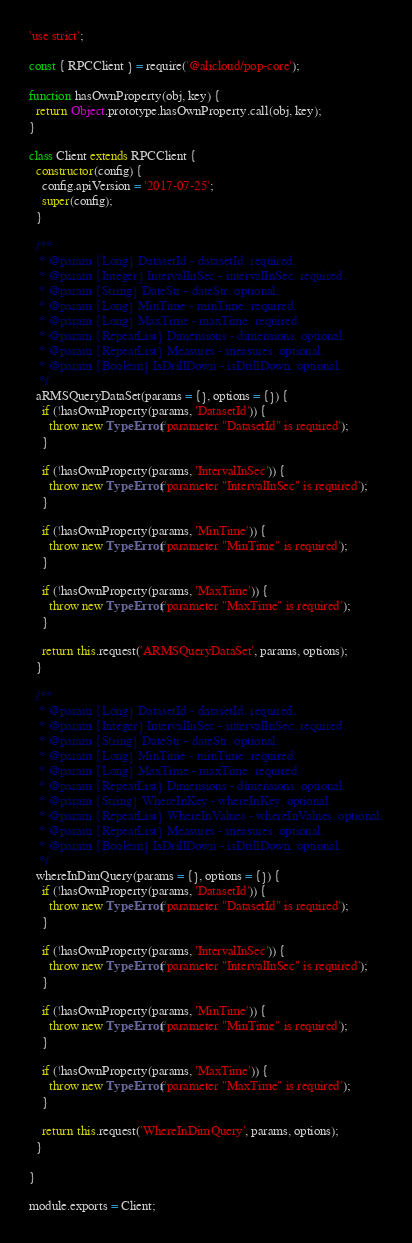<code> <loc_0><loc_0><loc_500><loc_500><_JavaScript_>
'use strict';

const { RPCClient } = require('@alicloud/pop-core');

function hasOwnProperty(obj, key) {
  return Object.prototype.hasOwnProperty.call(obj, key);
}

class Client extends RPCClient {
  constructor(config) {
    config.apiVersion = '2017-07-25';
    super(config);
  }

  /**
   * @param {Long} DatasetId - datasetId. required.
   * @param {Integer} IntervalInSec - intervalInSec. required.
   * @param {String} DateStr - dateStr. optional.
   * @param {Long} MinTime - minTime. required.
   * @param {Long} MaxTime - maxTime. required.
   * @param {RepeatList} Dimensions - dimensions. optional.
   * @param {RepeatList} Measures - measures. optional.
   * @param {Boolean} IsDrillDown - isDrillDown. optional.
   */
  aRMSQueryDataSet(params = {}, options = {}) {
    if (!hasOwnProperty(params, 'DatasetId')) {
      throw new TypeError('parameter "DatasetId" is required');
    }

    if (!hasOwnProperty(params, 'IntervalInSec')) {
      throw new TypeError('parameter "IntervalInSec" is required');
    }

    if (!hasOwnProperty(params, 'MinTime')) {
      throw new TypeError('parameter "MinTime" is required');
    }

    if (!hasOwnProperty(params, 'MaxTime')) {
      throw new TypeError('parameter "MaxTime" is required');
    }

    return this.request('ARMSQueryDataSet', params, options);
  }

  /**
   * @param {Long} DatasetId - datasetId. required.
   * @param {Integer} IntervalInSec - intervalInSec. required.
   * @param {String} DateStr - dateStr. optional.
   * @param {Long} MinTime - minTime. required.
   * @param {Long} MaxTime - maxTime. required.
   * @param {RepeatList} Dimensions - dimensions. optional.
   * @param {String} WhereInKey - whereInKey. optional.
   * @param {RepeatList} WhereInValues - whereInValues. optional.
   * @param {RepeatList} Measures - measures. optional.
   * @param {Boolean} IsDrillDown - isDrillDown. optional.
   */
  whereInDimQuery(params = {}, options = {}) {
    if (!hasOwnProperty(params, 'DatasetId')) {
      throw new TypeError('parameter "DatasetId" is required');
    }

    if (!hasOwnProperty(params, 'IntervalInSec')) {
      throw new TypeError('parameter "IntervalInSec" is required');
    }

    if (!hasOwnProperty(params, 'MinTime')) {
      throw new TypeError('parameter "MinTime" is required');
    }

    if (!hasOwnProperty(params, 'MaxTime')) {
      throw new TypeError('parameter "MaxTime" is required');
    }

    return this.request('WhereInDimQuery', params, options);
  }

}

module.exports = Client;
</code> 